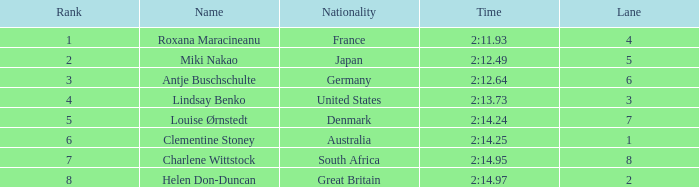What is the average Rank for a lane smaller than 3 with a nationality of Australia? 6.0. 